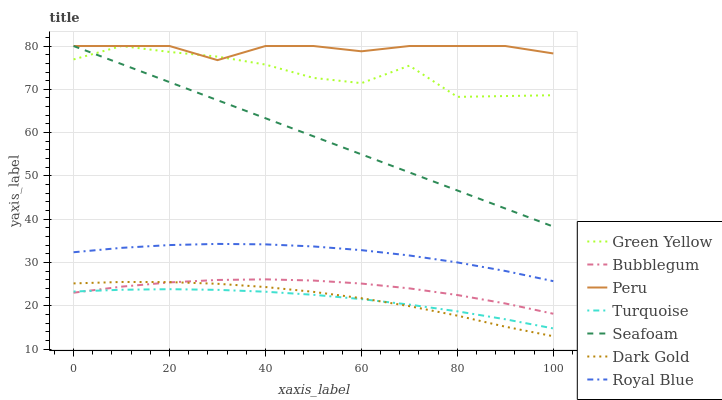Does Turquoise have the minimum area under the curve?
Answer yes or no. Yes. Does Peru have the maximum area under the curve?
Answer yes or no. Yes. Does Dark Gold have the minimum area under the curve?
Answer yes or no. No. Does Dark Gold have the maximum area under the curve?
Answer yes or no. No. Is Seafoam the smoothest?
Answer yes or no. Yes. Is Green Yellow the roughest?
Answer yes or no. Yes. Is Dark Gold the smoothest?
Answer yes or no. No. Is Dark Gold the roughest?
Answer yes or no. No. Does Dark Gold have the lowest value?
Answer yes or no. Yes. Does Seafoam have the lowest value?
Answer yes or no. No. Does Green Yellow have the highest value?
Answer yes or no. Yes. Does Dark Gold have the highest value?
Answer yes or no. No. Is Dark Gold less than Royal Blue?
Answer yes or no. Yes. Is Seafoam greater than Royal Blue?
Answer yes or no. Yes. Does Turquoise intersect Bubblegum?
Answer yes or no. Yes. Is Turquoise less than Bubblegum?
Answer yes or no. No. Is Turquoise greater than Bubblegum?
Answer yes or no. No. Does Dark Gold intersect Royal Blue?
Answer yes or no. No. 